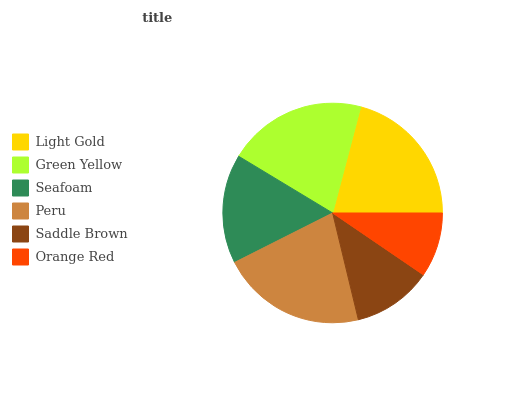Is Orange Red the minimum?
Answer yes or no. Yes. Is Peru the maximum?
Answer yes or no. Yes. Is Green Yellow the minimum?
Answer yes or no. No. Is Green Yellow the maximum?
Answer yes or no. No. Is Light Gold greater than Green Yellow?
Answer yes or no. Yes. Is Green Yellow less than Light Gold?
Answer yes or no. Yes. Is Green Yellow greater than Light Gold?
Answer yes or no. No. Is Light Gold less than Green Yellow?
Answer yes or no. No. Is Green Yellow the high median?
Answer yes or no. Yes. Is Seafoam the low median?
Answer yes or no. Yes. Is Light Gold the high median?
Answer yes or no. No. Is Light Gold the low median?
Answer yes or no. No. 